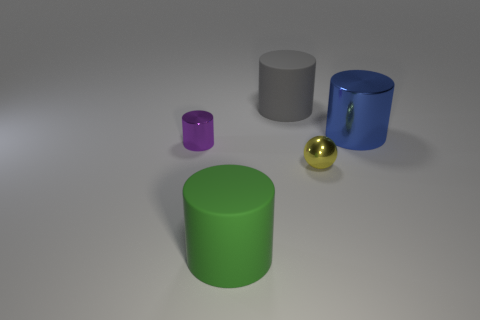Are there any big blue shiny balls?
Your response must be concise. No. There is a metallic object left of the large rubber object behind the blue metallic cylinder; what color is it?
Give a very brief answer. Purple. How many other objects are the same color as the large metal cylinder?
Provide a short and direct response. 0. How many objects are either small cyan metallic objects or large gray things on the right side of the purple object?
Make the answer very short. 1. There is a big rubber object right of the large green matte object; what is its color?
Offer a very short reply. Gray. The yellow object has what shape?
Provide a short and direct response. Sphere. The big thing in front of the shiny sphere to the right of the gray matte cylinder is made of what material?
Your answer should be compact. Rubber. What number of other objects are there of the same material as the small ball?
Provide a short and direct response. 2. There is a green object that is the same size as the gray cylinder; what is it made of?
Your answer should be very brief. Rubber. Is the number of gray things that are in front of the green cylinder greater than the number of spheres behind the blue metal cylinder?
Offer a terse response. No. 